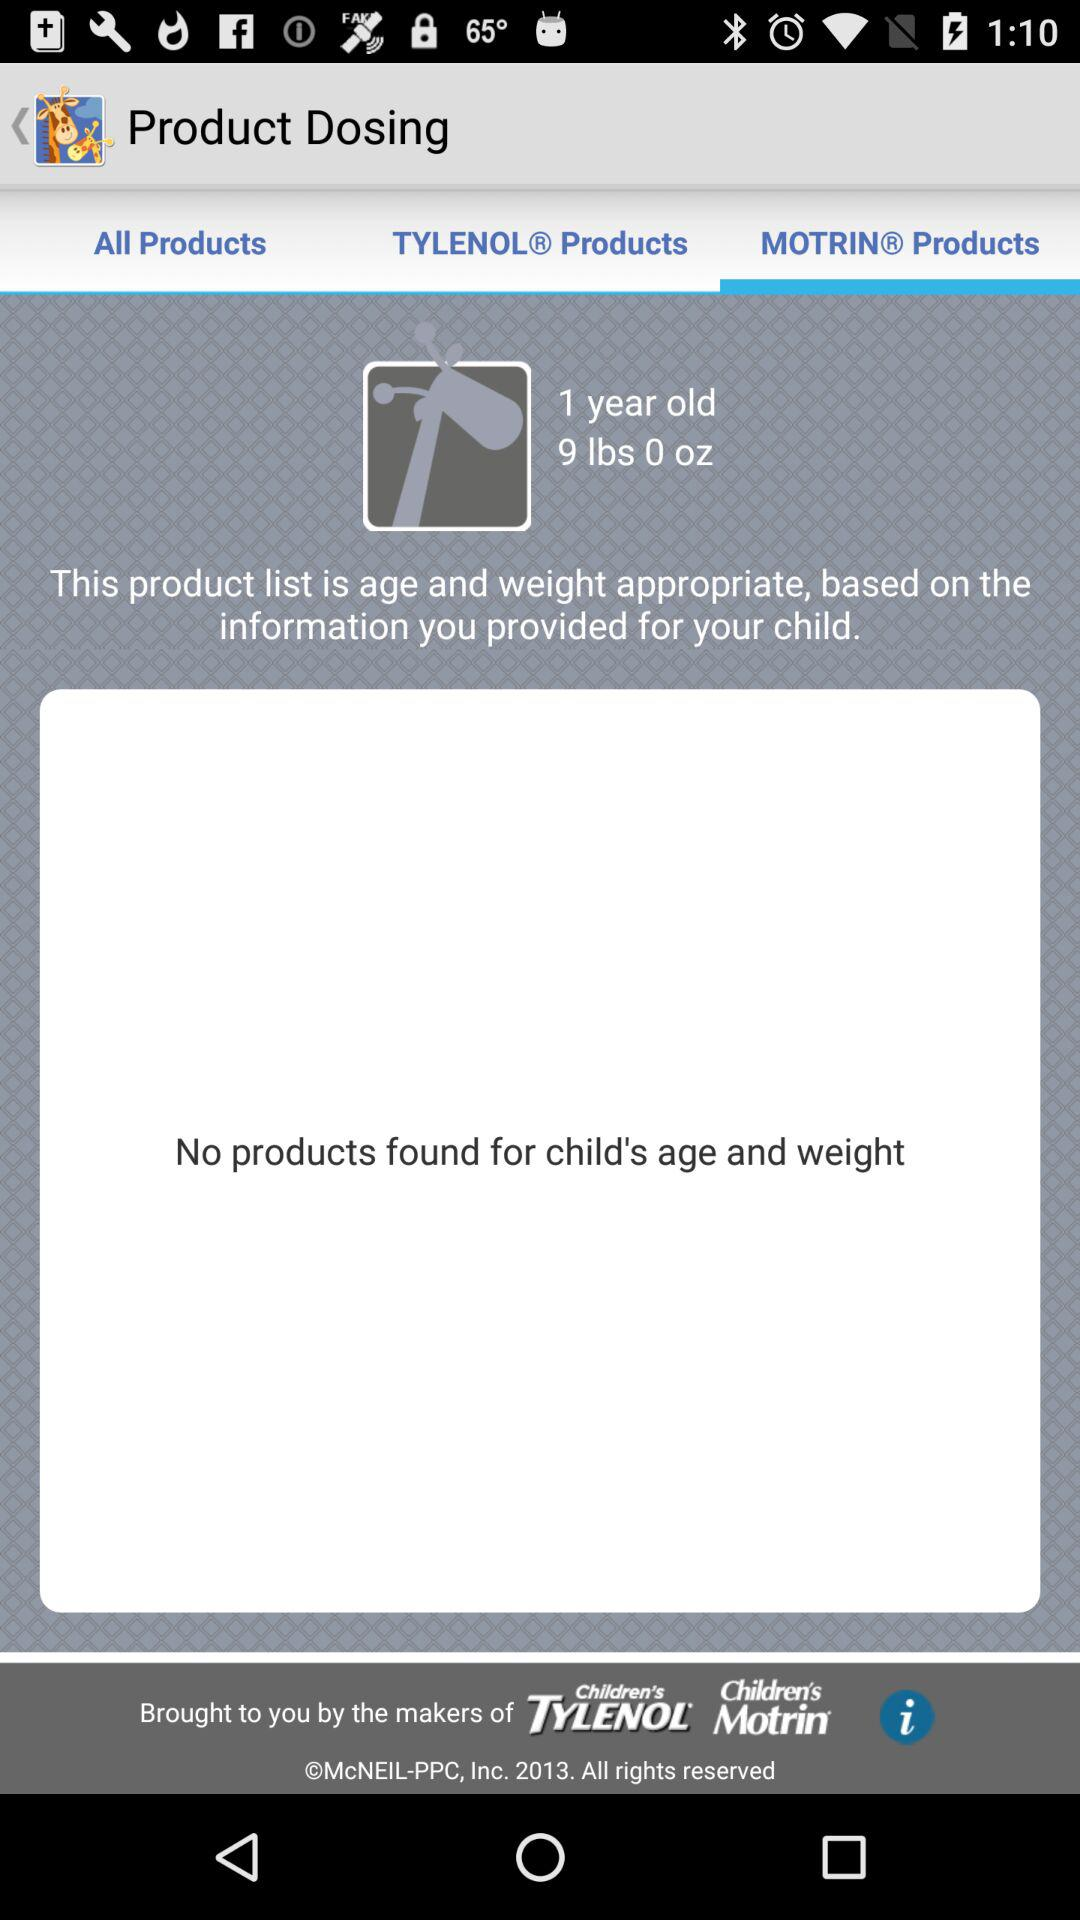Is the child male or female?
When the provided information is insufficient, respond with <no answer>. <no answer> 